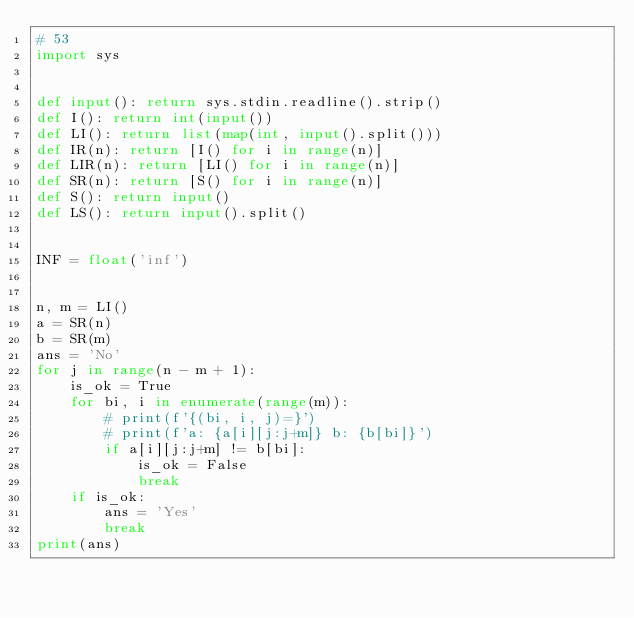Convert code to text. <code><loc_0><loc_0><loc_500><loc_500><_Python_># 53
import sys


def input(): return sys.stdin.readline().strip()
def I(): return int(input())
def LI(): return list(map(int, input().split()))
def IR(n): return [I() for i in range(n)]
def LIR(n): return [LI() for i in range(n)]
def SR(n): return [S() for i in range(n)]
def S(): return input()
def LS(): return input().split()


INF = float('inf')


n, m = LI()
a = SR(n)
b = SR(m)
ans = 'No'
for j in range(n - m + 1):
    is_ok = True
    for bi, i in enumerate(range(m)):
        # print(f'{(bi, i, j)=}')
        # print(f'a: {a[i][j:j+m]} b: {b[bi]}')
        if a[i][j:j+m] != b[bi]:
            is_ok = False
            break
    if is_ok:
        ans = 'Yes'
        break
print(ans)
</code> 